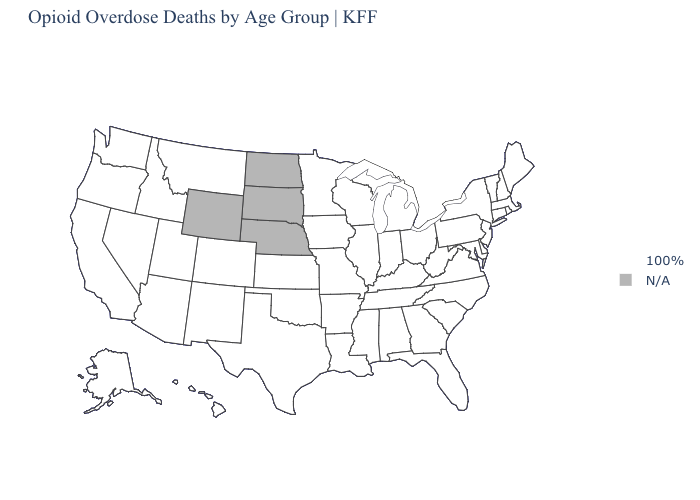Name the states that have a value in the range N/A?
Quick response, please. Nebraska, North Dakota, South Dakota, Wyoming. What is the value of Idaho?
Be succinct. 100%. What is the value of Alaska?
Keep it brief. 100%. Does the map have missing data?
Give a very brief answer. Yes. What is the value of New Jersey?
Give a very brief answer. 100%. Which states have the lowest value in the South?
Quick response, please. Alabama, Arkansas, Delaware, Florida, Georgia, Kentucky, Louisiana, Maryland, Mississippi, North Carolina, Oklahoma, South Carolina, Tennessee, Texas, Virginia, West Virginia. What is the value of Ohio?
Give a very brief answer. 100%. What is the highest value in the West ?
Give a very brief answer. 100%. What is the highest value in states that border South Dakota?
Write a very short answer. 100%. Name the states that have a value in the range N/A?
Write a very short answer. Nebraska, North Dakota, South Dakota, Wyoming. Does the first symbol in the legend represent the smallest category?
Concise answer only. No. What is the value of Nevada?
Quick response, please. 100%. 